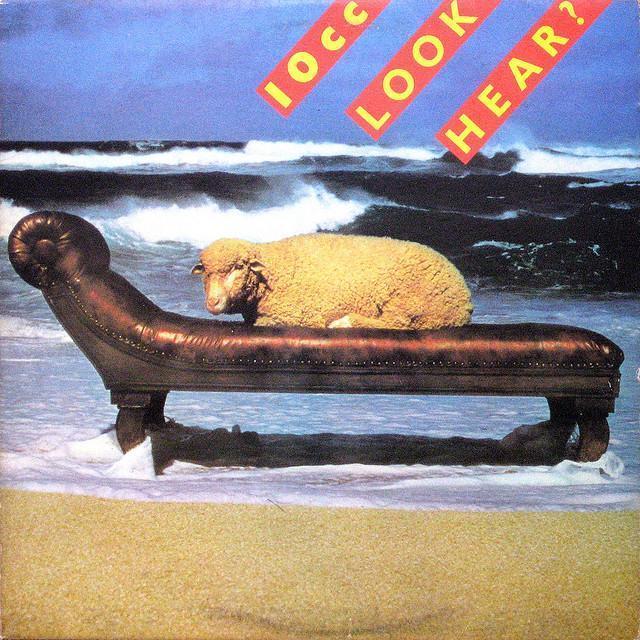How many couches are there?
Give a very brief answer. 1. How many beds are visible?
Give a very brief answer. 1. How many people are there?
Give a very brief answer. 0. 